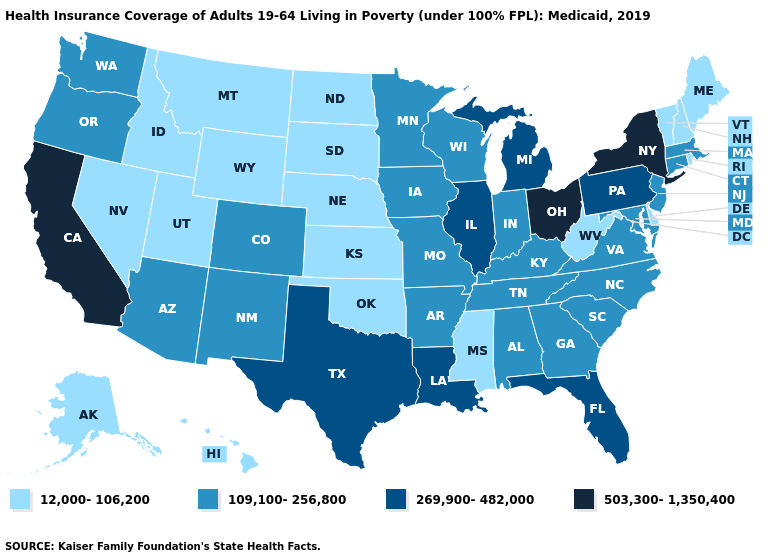Does Iowa have the lowest value in the MidWest?
Short answer required. No. Does Pennsylvania have the same value as Florida?
Give a very brief answer. Yes. What is the highest value in states that border California?
Be succinct. 109,100-256,800. Does Nevada have a lower value than Alaska?
Be succinct. No. What is the value of South Carolina?
Concise answer only. 109,100-256,800. Does Arkansas have the lowest value in the South?
Keep it brief. No. Does Maine have the same value as North Dakota?
Quick response, please. Yes. Does Virginia have a lower value than Ohio?
Give a very brief answer. Yes. What is the lowest value in the South?
Concise answer only. 12,000-106,200. Name the states that have a value in the range 12,000-106,200?
Short answer required. Alaska, Delaware, Hawaii, Idaho, Kansas, Maine, Mississippi, Montana, Nebraska, Nevada, New Hampshire, North Dakota, Oklahoma, Rhode Island, South Dakota, Utah, Vermont, West Virginia, Wyoming. What is the highest value in the South ?
Give a very brief answer. 269,900-482,000. Name the states that have a value in the range 503,300-1,350,400?
Write a very short answer. California, New York, Ohio. Does Alabama have a higher value than Mississippi?
Answer briefly. Yes. Among the states that border California , which have the highest value?
Short answer required. Arizona, Oregon. Name the states that have a value in the range 109,100-256,800?
Answer briefly. Alabama, Arizona, Arkansas, Colorado, Connecticut, Georgia, Indiana, Iowa, Kentucky, Maryland, Massachusetts, Minnesota, Missouri, New Jersey, New Mexico, North Carolina, Oregon, South Carolina, Tennessee, Virginia, Washington, Wisconsin. 